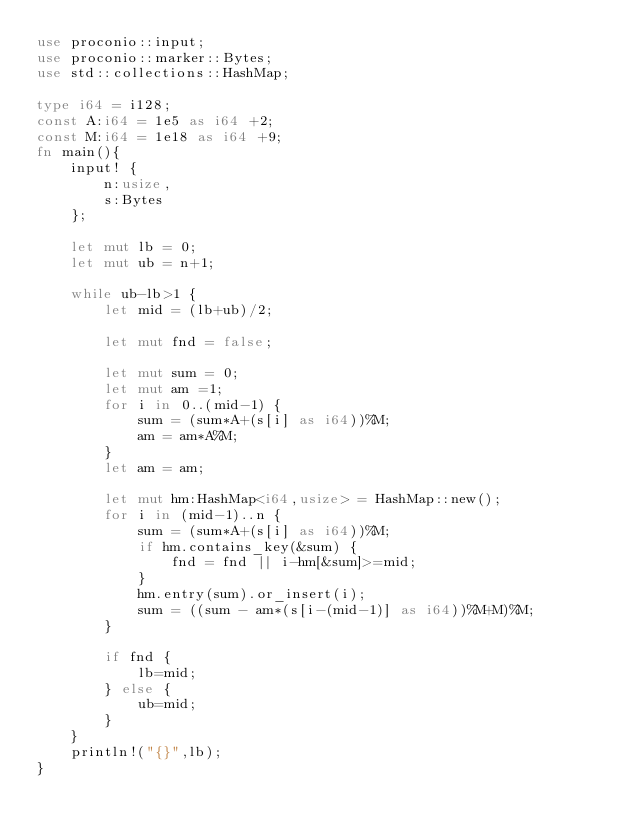Convert code to text. <code><loc_0><loc_0><loc_500><loc_500><_Rust_>use proconio::input;
use proconio::marker::Bytes;
use std::collections::HashMap;

type i64 = i128;
const A:i64 = 1e5 as i64 +2;
const M:i64 = 1e18 as i64 +9;
fn main(){
    input! {
        n:usize,
        s:Bytes
    };
    
    let mut lb = 0;
    let mut ub = n+1;

    while ub-lb>1 {
        let mid = (lb+ub)/2;

        let mut fnd = false;

        let mut sum = 0;
        let mut am =1;
        for i in 0..(mid-1) {
            sum = (sum*A+(s[i] as i64))%M;
            am = am*A%M;
        }
        let am = am;

        let mut hm:HashMap<i64,usize> = HashMap::new();
        for i in (mid-1)..n {
            sum = (sum*A+(s[i] as i64))%M;
            if hm.contains_key(&sum) {
                fnd = fnd || i-hm[&sum]>=mid;
            }
            hm.entry(sum).or_insert(i);
            sum = ((sum - am*(s[i-(mid-1)] as i64))%M+M)%M;
        }

        if fnd {
            lb=mid;
        } else {
            ub=mid;
        }
    }
    println!("{}",lb);
}

</code> 